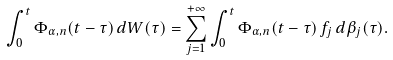Convert formula to latex. <formula><loc_0><loc_0><loc_500><loc_500>\int _ { 0 } ^ { t } \Phi _ { \alpha , n } ( t - \tau ) \, d W ( \tau ) = \sum _ { j = 1 } ^ { + \infty } \int _ { 0 } ^ { t } \Phi _ { \alpha , n } ( t - \tau ) \, f _ { j } \, d \beta _ { j } ( \tau ) .</formula> 